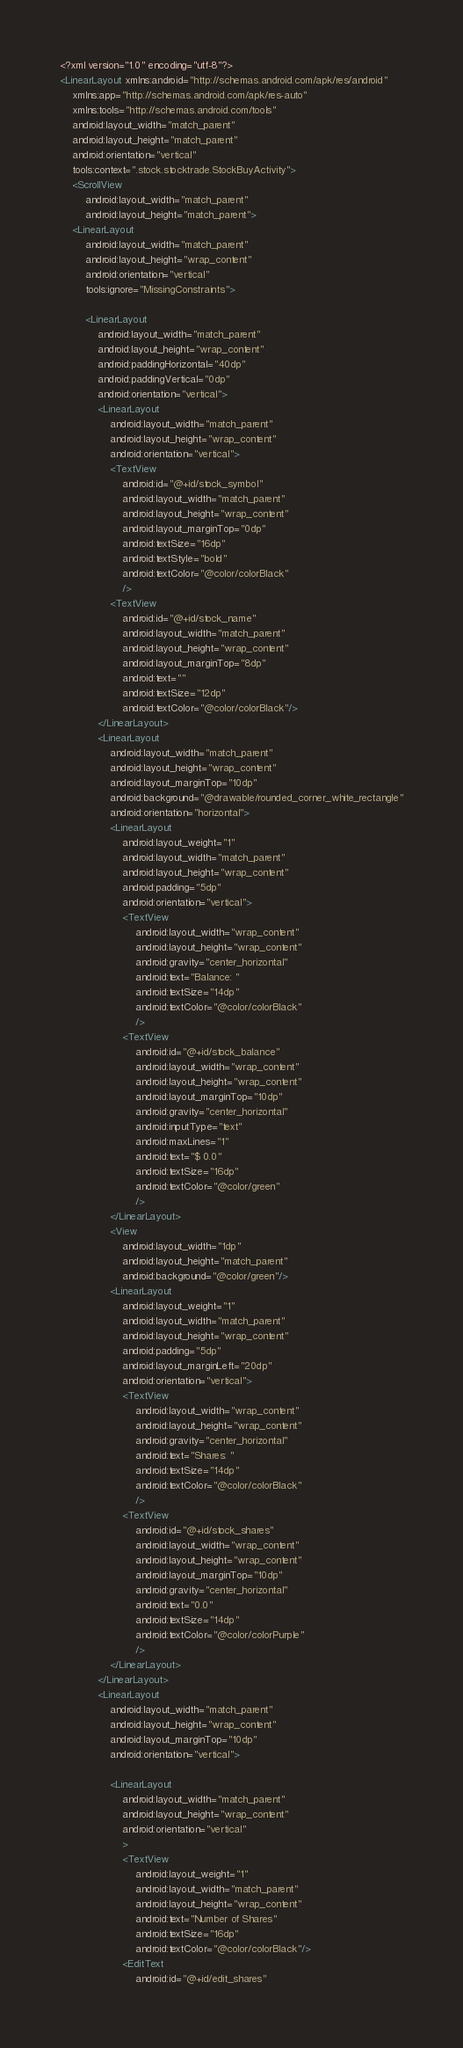Convert code to text. <code><loc_0><loc_0><loc_500><loc_500><_XML_><?xml version="1.0" encoding="utf-8"?>
<LinearLayout xmlns:android="http://schemas.android.com/apk/res/android"
    xmlns:app="http://schemas.android.com/apk/res-auto"
    xmlns:tools="http://schemas.android.com/tools"
    android:layout_width="match_parent"
    android:layout_height="match_parent"
    android:orientation="vertical"
    tools:context=".stock.stocktrade.StockBuyActivity">
    <ScrollView
        android:layout_width="match_parent"
        android:layout_height="match_parent">
    <LinearLayout
        android:layout_width="match_parent"
        android:layout_height="wrap_content"
        android:orientation="vertical"
        tools:ignore="MissingConstraints">

        <LinearLayout
            android:layout_width="match_parent"
            android:layout_height="wrap_content"
            android:paddingHorizontal="40dp"
            android:paddingVertical="0dp"
            android:orientation="vertical">
            <LinearLayout
                android:layout_width="match_parent"
                android:layout_height="wrap_content"
                android:orientation="vertical">
                <TextView
                    android:id="@+id/stock_symbol"
                    android:layout_width="match_parent"
                    android:layout_height="wrap_content"
                    android:layout_marginTop="0dp"
                    android:textSize="16dp"
                    android:textStyle="bold"
                    android:textColor="@color/colorBlack"
                    />
                <TextView
                    android:id="@+id/stock_name"
                    android:layout_width="match_parent"
                    android:layout_height="wrap_content"
                    android:layout_marginTop="8dp"
                    android:text=""
                    android:textSize="12dp"
                    android:textColor="@color/colorBlack"/>
            </LinearLayout>
            <LinearLayout
                android:layout_width="match_parent"
                android:layout_height="wrap_content"
                android:layout_marginTop="10dp"
                android:background="@drawable/rounded_corner_white_rectangle"
                android:orientation="horizontal">
                <LinearLayout
                    android:layout_weight="1"
                    android:layout_width="match_parent"
                    android:layout_height="wrap_content"
                    android:padding="5dp"
                    android:orientation="vertical">
                    <TextView
                        android:layout_width="wrap_content"
                        android:layout_height="wrap_content"
                        android:gravity="center_horizontal"
                        android:text="Balance: "
                        android:textSize="14dp"
                        android:textColor="@color/colorBlack"
                        />
                    <TextView
                        android:id="@+id/stock_balance"
                        android:layout_width="wrap_content"
                        android:layout_height="wrap_content"
                        android:layout_marginTop="10dp"
                        android:gravity="center_horizontal"
                        android:inputType="text"
                        android:maxLines="1"
                        android:text="$ 0.0"
                        android:textSize="16dp"
                        android:textColor="@color/green"
                        />
                </LinearLayout>
                <View
                    android:layout_width="1dp"
                    android:layout_height="match_parent"
                    android:background="@color/green"/>
                <LinearLayout
                    android:layout_weight="1"
                    android:layout_width="match_parent"
                    android:layout_height="wrap_content"
                    android:padding="5dp"
                    android:layout_marginLeft="20dp"
                    android:orientation="vertical">
                    <TextView
                        android:layout_width="wrap_content"
                        android:layout_height="wrap_content"
                        android:gravity="center_horizontal"
                        android:text="Shares: "
                        android:textSize="14dp"
                        android:textColor="@color/colorBlack"
                        />
                    <TextView
                        android:id="@+id/stock_shares"
                        android:layout_width="wrap_content"
                        android:layout_height="wrap_content"
                        android:layout_marginTop="10dp"
                        android:gravity="center_horizontal"
                        android:text="0.0"
                        android:textSize="14dp"
                        android:textColor="@color/colorPurple"
                        />
                </LinearLayout>
            </LinearLayout>
            <LinearLayout
                android:layout_width="match_parent"
                android:layout_height="wrap_content"
                android:layout_marginTop="10dp"
                android:orientation="vertical">

                <LinearLayout
                    android:layout_width="match_parent"
                    android:layout_height="wrap_content"
                    android:orientation="vertical"
                    >
                    <TextView
                        android:layout_weight="1"
                        android:layout_width="match_parent"
                        android:layout_height="wrap_content"
                        android:text="Number of Shares"
                        android:textSize="16dp"
                        android:textColor="@color/colorBlack"/>
                    <EditText
                        android:id="@+id/edit_shares"</code> 